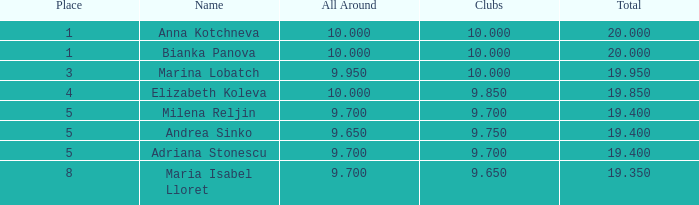What are the bottom clubs with a position above 5, having an overall higher than None. 